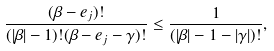<formula> <loc_0><loc_0><loc_500><loc_500>\frac { ( \beta - e _ { j } ) ! } { ( | \beta | - 1 ) ! ( \beta - e _ { j } - \gamma ) ! } \leq \frac { 1 } { ( | \beta | - 1 - | \gamma | ) ! } ,</formula> 